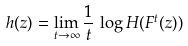<formula> <loc_0><loc_0><loc_500><loc_500>h ( z ) = \lim _ { t \to \infty } \frac { 1 } { t } \, \log H ( F ^ { t } ( z ) )</formula> 